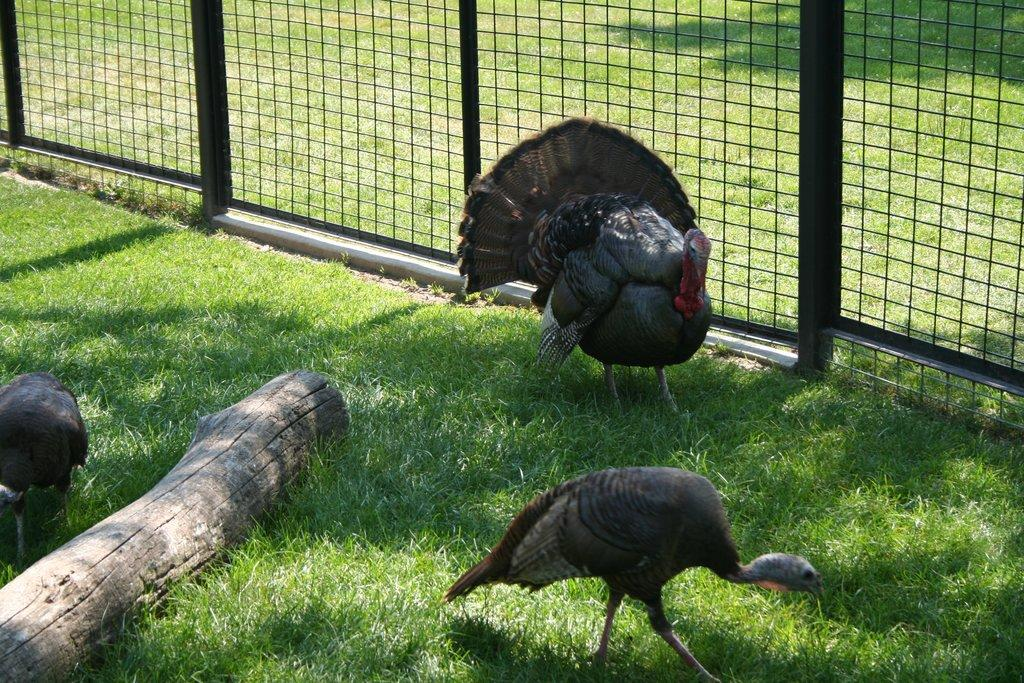What type of animals can be seen in the image? There are birds in the image. What type of vegetation is visible at the bottom of the image? There is grass at the bottom of the image. What type of structure is present in the image? There is fencing in the image. What type of hair can be seen on the birds in the image? There is no hair visible on the birds in the image; birds have feathers, not hair. 